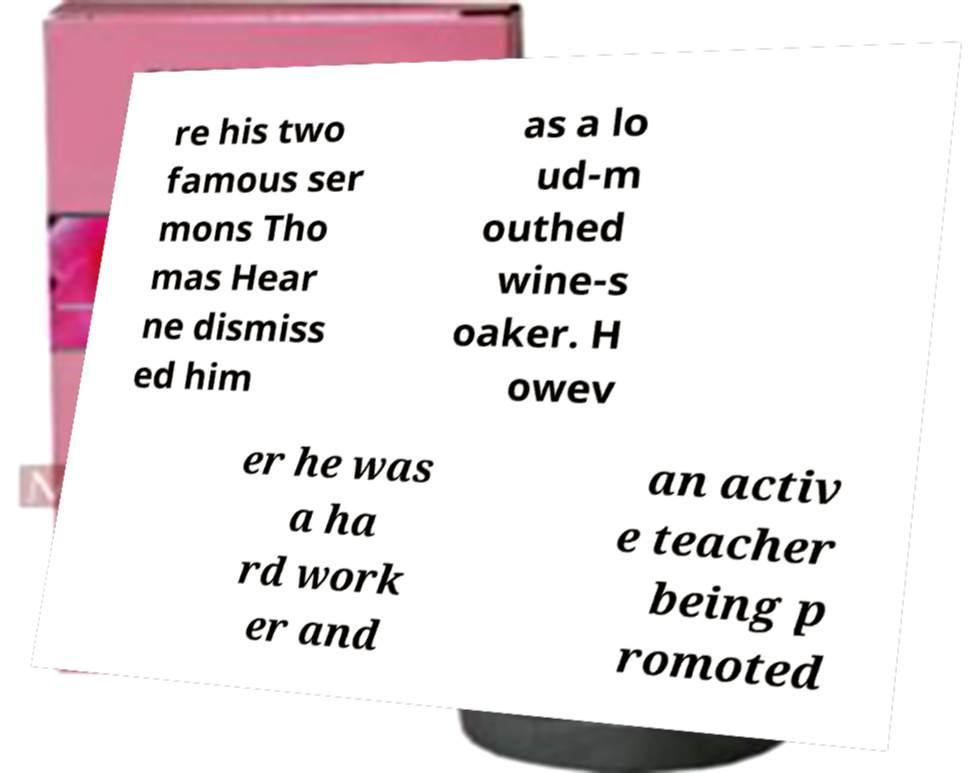Can you accurately transcribe the text from the provided image for me? re his two famous ser mons Tho mas Hear ne dismiss ed him as a lo ud-m outhed wine-s oaker. H owev er he was a ha rd work er and an activ e teacher being p romoted 